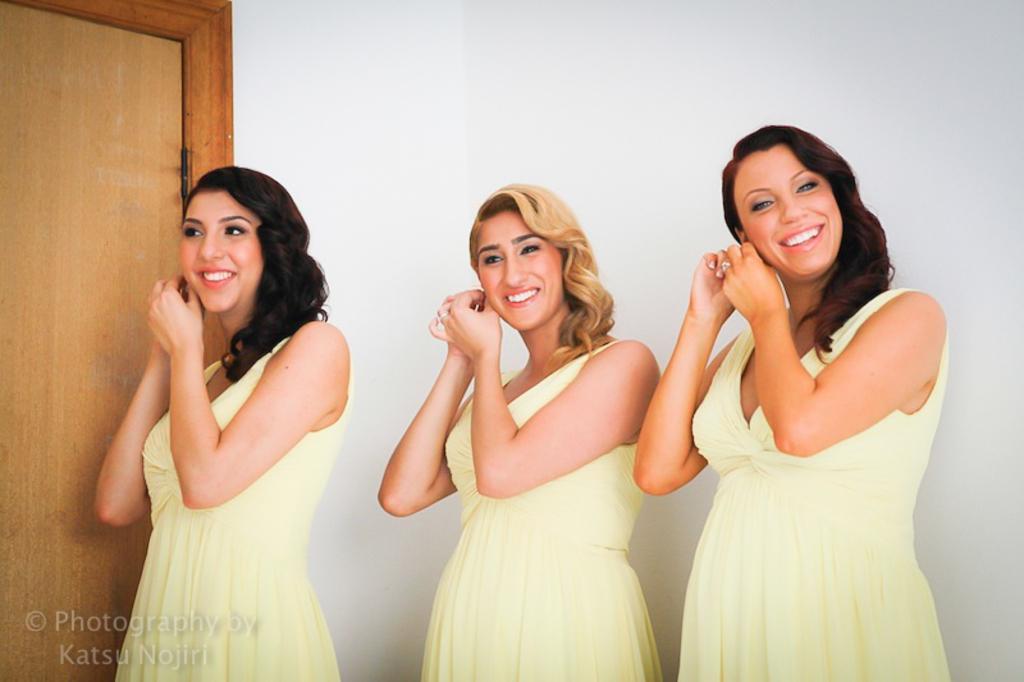Can you describe this image briefly? In this image, we can see three ladies standing and smiling and in the background, there is a door and a wall. At the bottom, we can see some text. 